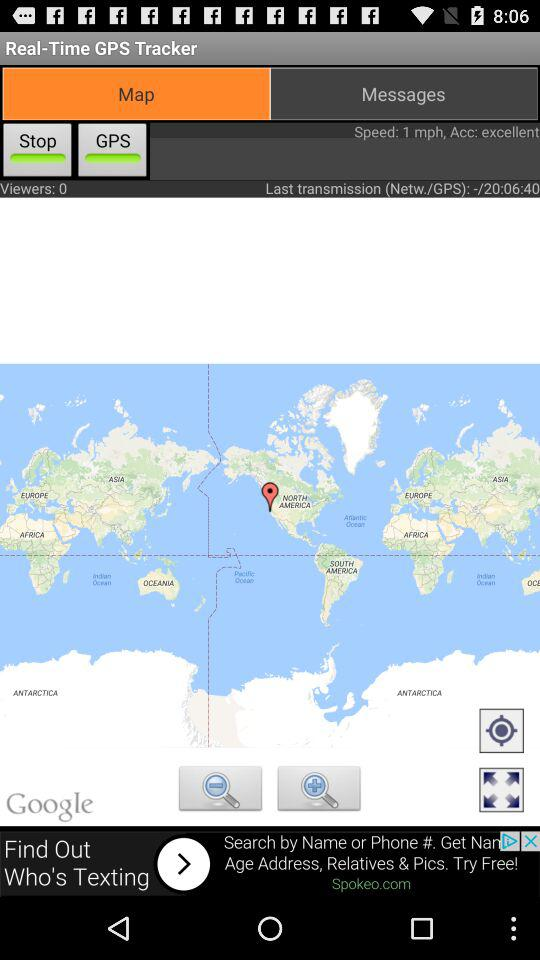How many viewers are there? There are 0 viewers. 